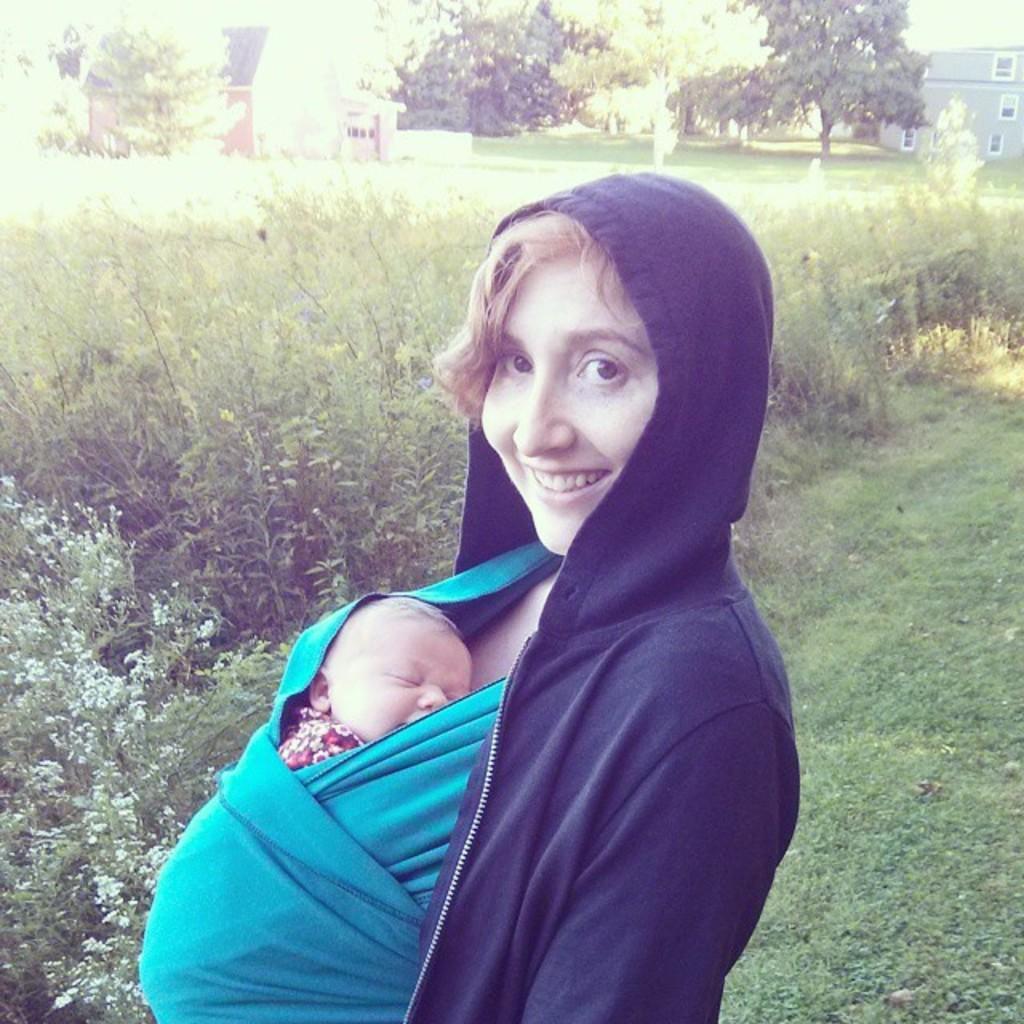How would you summarize this image in a sentence or two? In the center of the image, we can see a lady smiling and holding a baby and in the background, there are buildings and we can see trees and plants. At the bottom, there is ground. 